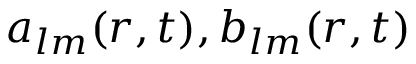Convert formula to latex. <formula><loc_0><loc_0><loc_500><loc_500>a _ { l m } ( r , t ) , b _ { l m } ( r , t )</formula> 